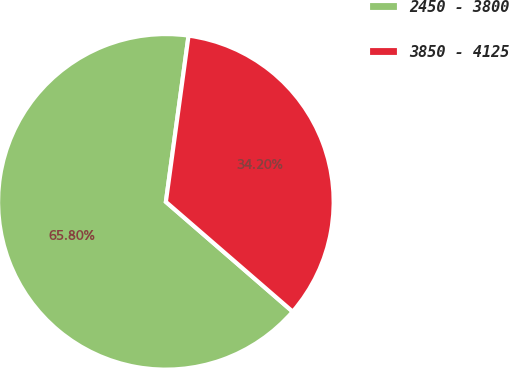Convert chart to OTSL. <chart><loc_0><loc_0><loc_500><loc_500><pie_chart><fcel>2450 - 3800<fcel>3850 - 4125<nl><fcel>65.8%<fcel>34.2%<nl></chart> 